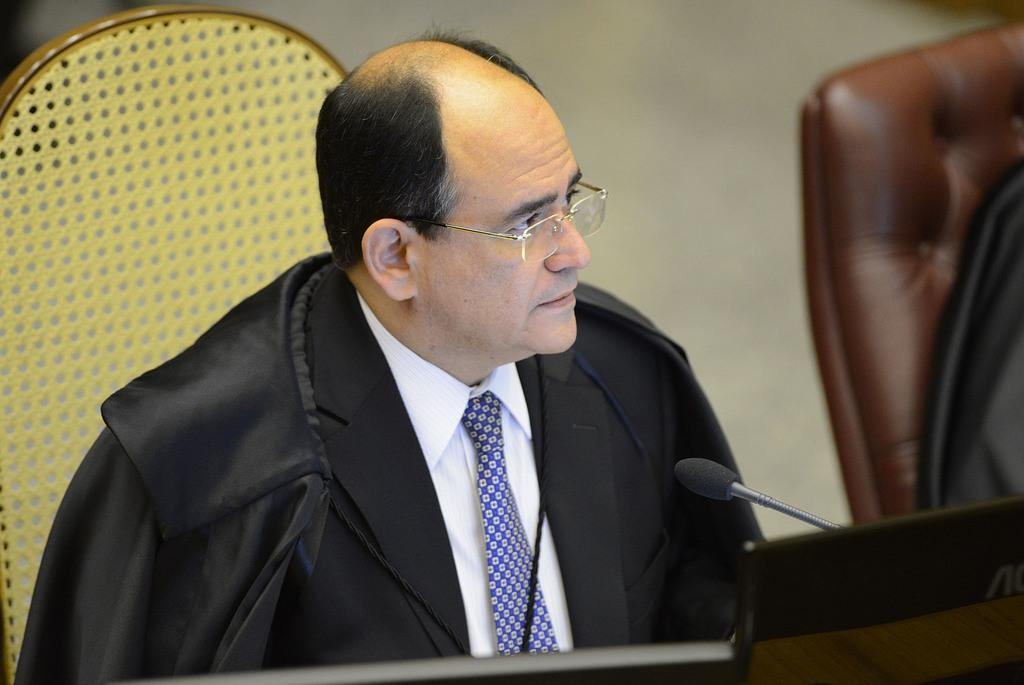Who is in the image? There is a person in the image. What is the person wearing? The person is wearing a black suit and a white shirt. What is the person doing in the image? The person is sitting on a chair. What object is present in the image that is typically used for amplifying sound? There is a microphone in the image. Where is the toad located in the image? There is no toad present in the image. What is the purpose of the mailbox in the image? There is no mailbox present in the image. 